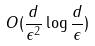<formula> <loc_0><loc_0><loc_500><loc_500>O ( \frac { d } { \epsilon ^ { 2 } } \log \frac { d } { \epsilon } )</formula> 